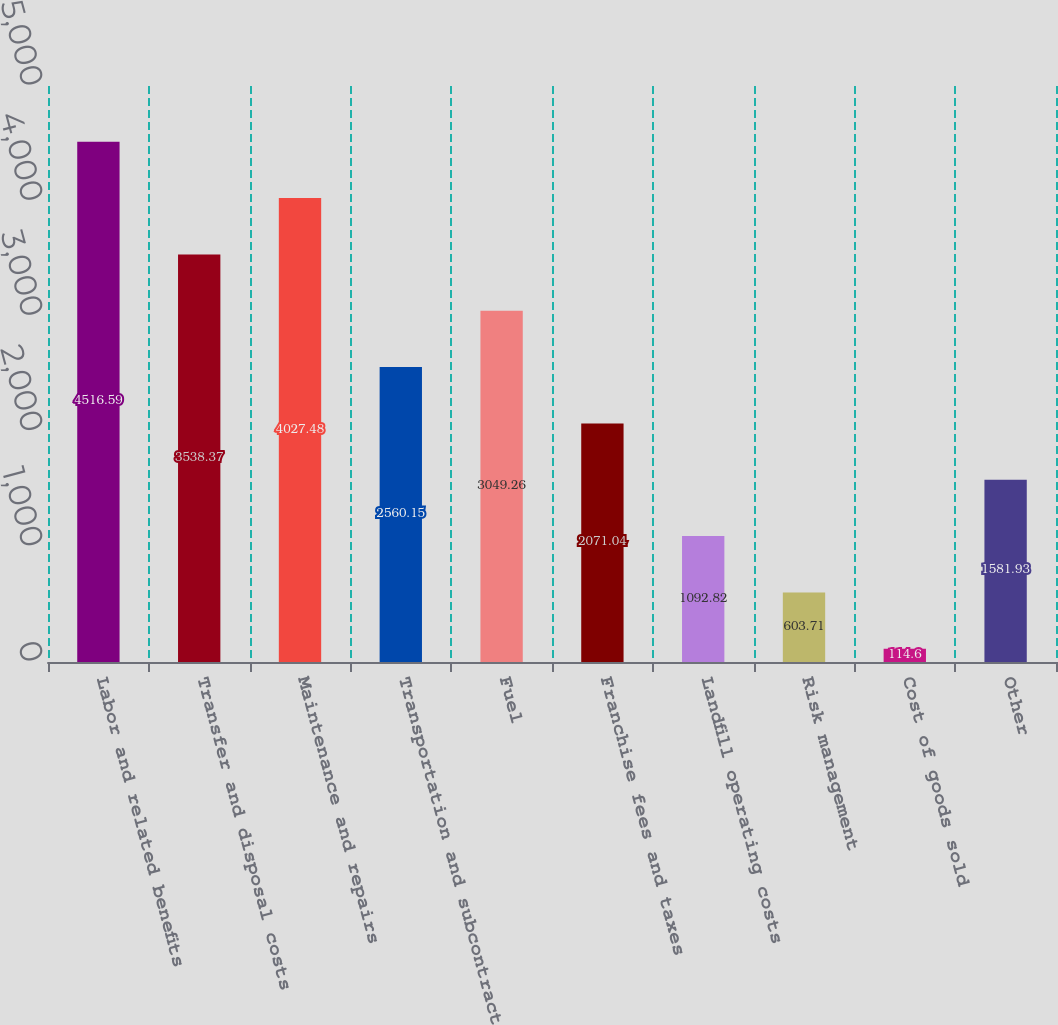Convert chart to OTSL. <chart><loc_0><loc_0><loc_500><loc_500><bar_chart><fcel>Labor and related benefits<fcel>Transfer and disposal costs<fcel>Maintenance and repairs<fcel>Transportation and subcontract<fcel>Fuel<fcel>Franchise fees and taxes<fcel>Landfill operating costs<fcel>Risk management<fcel>Cost of goods sold<fcel>Other<nl><fcel>4516.59<fcel>3538.37<fcel>4027.48<fcel>2560.15<fcel>3049.26<fcel>2071.04<fcel>1092.82<fcel>603.71<fcel>114.6<fcel>1581.93<nl></chart> 